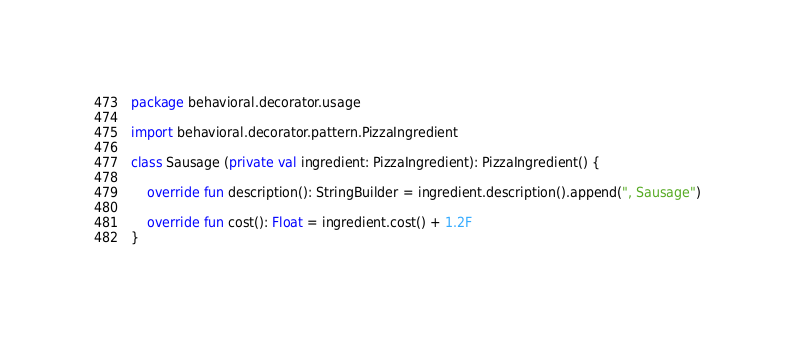Convert code to text. <code><loc_0><loc_0><loc_500><loc_500><_Kotlin_>package behavioral.decorator.usage

import behavioral.decorator.pattern.PizzaIngredient

class Sausage (private val ingredient: PizzaIngredient): PizzaIngredient() {

    override fun description(): StringBuilder = ingredient.description().append(", Sausage")

    override fun cost(): Float = ingredient.cost() + 1.2F
}</code> 